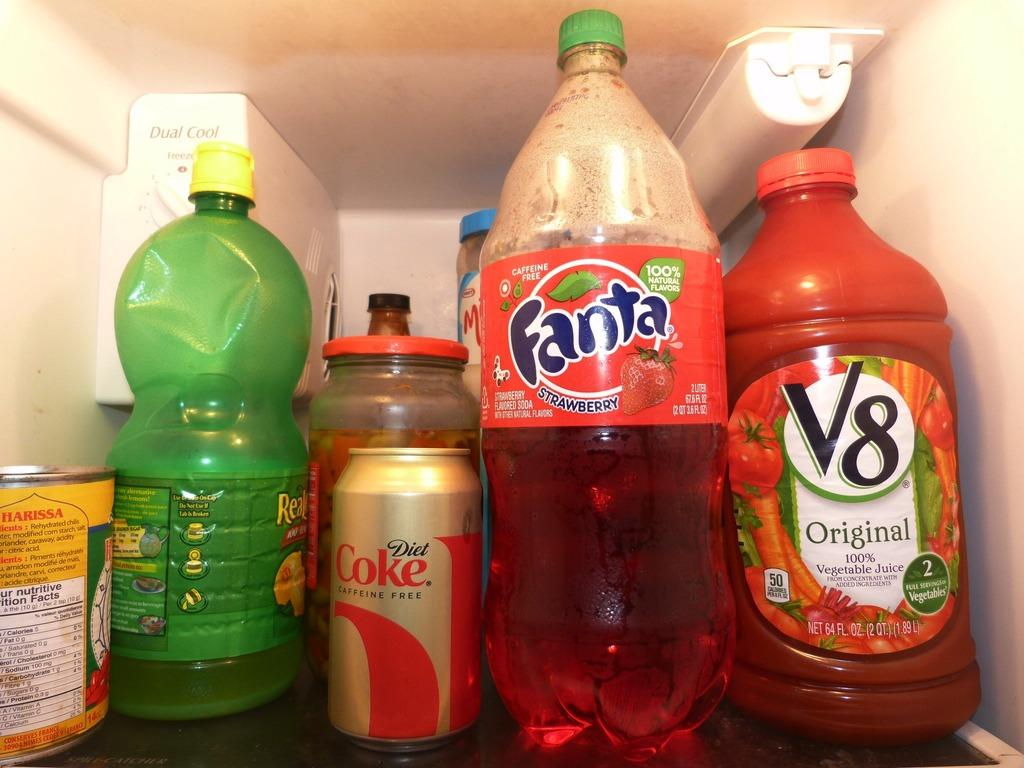<image>
Provide a brief description of the given image. the inside of a refrigerator with a bottle of strawberry fanta in it 